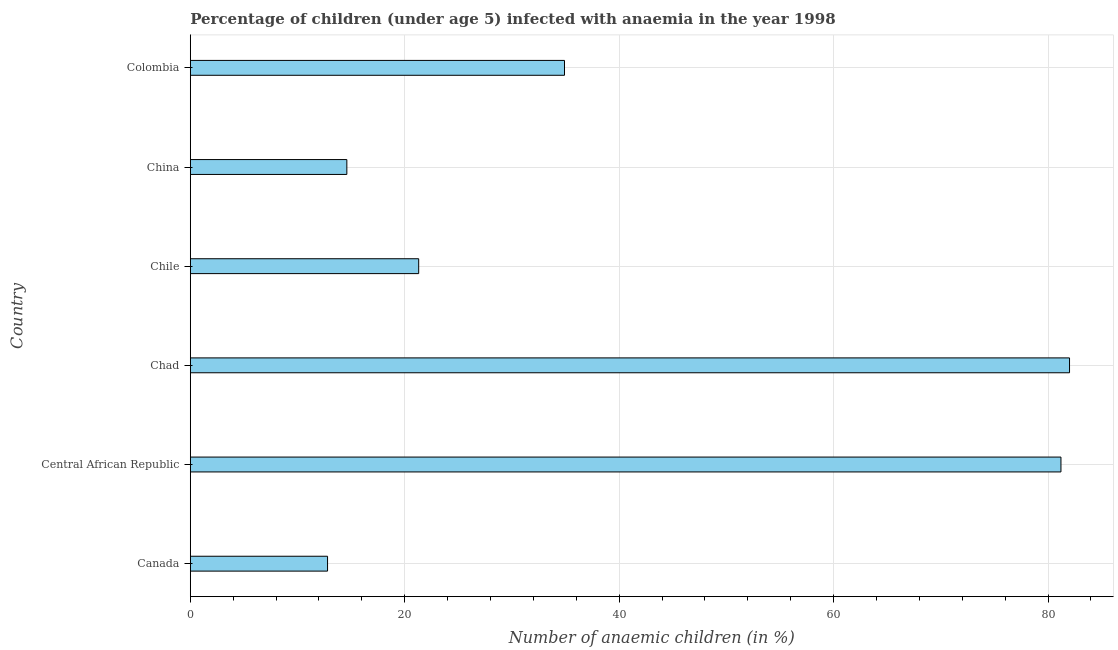Does the graph contain any zero values?
Offer a terse response. No. What is the title of the graph?
Offer a terse response. Percentage of children (under age 5) infected with anaemia in the year 1998. What is the label or title of the X-axis?
Give a very brief answer. Number of anaemic children (in %). What is the number of anaemic children in Chile?
Provide a short and direct response. 21.3. Across all countries, what is the minimum number of anaemic children?
Ensure brevity in your answer.  12.8. In which country was the number of anaemic children maximum?
Provide a succinct answer. Chad. In which country was the number of anaemic children minimum?
Make the answer very short. Canada. What is the sum of the number of anaemic children?
Offer a very short reply. 246.8. What is the difference between the number of anaemic children in Canada and Central African Republic?
Provide a succinct answer. -68.4. What is the average number of anaemic children per country?
Offer a terse response. 41.13. What is the median number of anaemic children?
Your answer should be very brief. 28.1. Is the number of anaemic children in Canada less than that in Chile?
Your answer should be very brief. Yes. Is the difference between the number of anaemic children in Canada and Chile greater than the difference between any two countries?
Offer a very short reply. No. What is the difference between the highest and the lowest number of anaemic children?
Ensure brevity in your answer.  69.2. In how many countries, is the number of anaemic children greater than the average number of anaemic children taken over all countries?
Provide a short and direct response. 2. What is the Number of anaemic children (in %) of Central African Republic?
Your answer should be very brief. 81.2. What is the Number of anaemic children (in %) of Chad?
Ensure brevity in your answer.  82. What is the Number of anaemic children (in %) in Chile?
Keep it short and to the point. 21.3. What is the Number of anaemic children (in %) in Colombia?
Offer a very short reply. 34.9. What is the difference between the Number of anaemic children (in %) in Canada and Central African Republic?
Offer a very short reply. -68.4. What is the difference between the Number of anaemic children (in %) in Canada and Chad?
Your answer should be very brief. -69.2. What is the difference between the Number of anaemic children (in %) in Canada and Colombia?
Provide a succinct answer. -22.1. What is the difference between the Number of anaemic children (in %) in Central African Republic and Chile?
Your answer should be very brief. 59.9. What is the difference between the Number of anaemic children (in %) in Central African Republic and China?
Keep it short and to the point. 66.6. What is the difference between the Number of anaemic children (in %) in Central African Republic and Colombia?
Your response must be concise. 46.3. What is the difference between the Number of anaemic children (in %) in Chad and Chile?
Make the answer very short. 60.7. What is the difference between the Number of anaemic children (in %) in Chad and China?
Offer a terse response. 67.4. What is the difference between the Number of anaemic children (in %) in Chad and Colombia?
Your answer should be compact. 47.1. What is the difference between the Number of anaemic children (in %) in Chile and Colombia?
Provide a succinct answer. -13.6. What is the difference between the Number of anaemic children (in %) in China and Colombia?
Offer a very short reply. -20.3. What is the ratio of the Number of anaemic children (in %) in Canada to that in Central African Republic?
Provide a short and direct response. 0.16. What is the ratio of the Number of anaemic children (in %) in Canada to that in Chad?
Make the answer very short. 0.16. What is the ratio of the Number of anaemic children (in %) in Canada to that in Chile?
Give a very brief answer. 0.6. What is the ratio of the Number of anaemic children (in %) in Canada to that in China?
Keep it short and to the point. 0.88. What is the ratio of the Number of anaemic children (in %) in Canada to that in Colombia?
Your answer should be compact. 0.37. What is the ratio of the Number of anaemic children (in %) in Central African Republic to that in Chad?
Make the answer very short. 0.99. What is the ratio of the Number of anaemic children (in %) in Central African Republic to that in Chile?
Your response must be concise. 3.81. What is the ratio of the Number of anaemic children (in %) in Central African Republic to that in China?
Provide a short and direct response. 5.56. What is the ratio of the Number of anaemic children (in %) in Central African Republic to that in Colombia?
Keep it short and to the point. 2.33. What is the ratio of the Number of anaemic children (in %) in Chad to that in Chile?
Make the answer very short. 3.85. What is the ratio of the Number of anaemic children (in %) in Chad to that in China?
Your answer should be very brief. 5.62. What is the ratio of the Number of anaemic children (in %) in Chad to that in Colombia?
Keep it short and to the point. 2.35. What is the ratio of the Number of anaemic children (in %) in Chile to that in China?
Give a very brief answer. 1.46. What is the ratio of the Number of anaemic children (in %) in Chile to that in Colombia?
Make the answer very short. 0.61. What is the ratio of the Number of anaemic children (in %) in China to that in Colombia?
Provide a short and direct response. 0.42. 